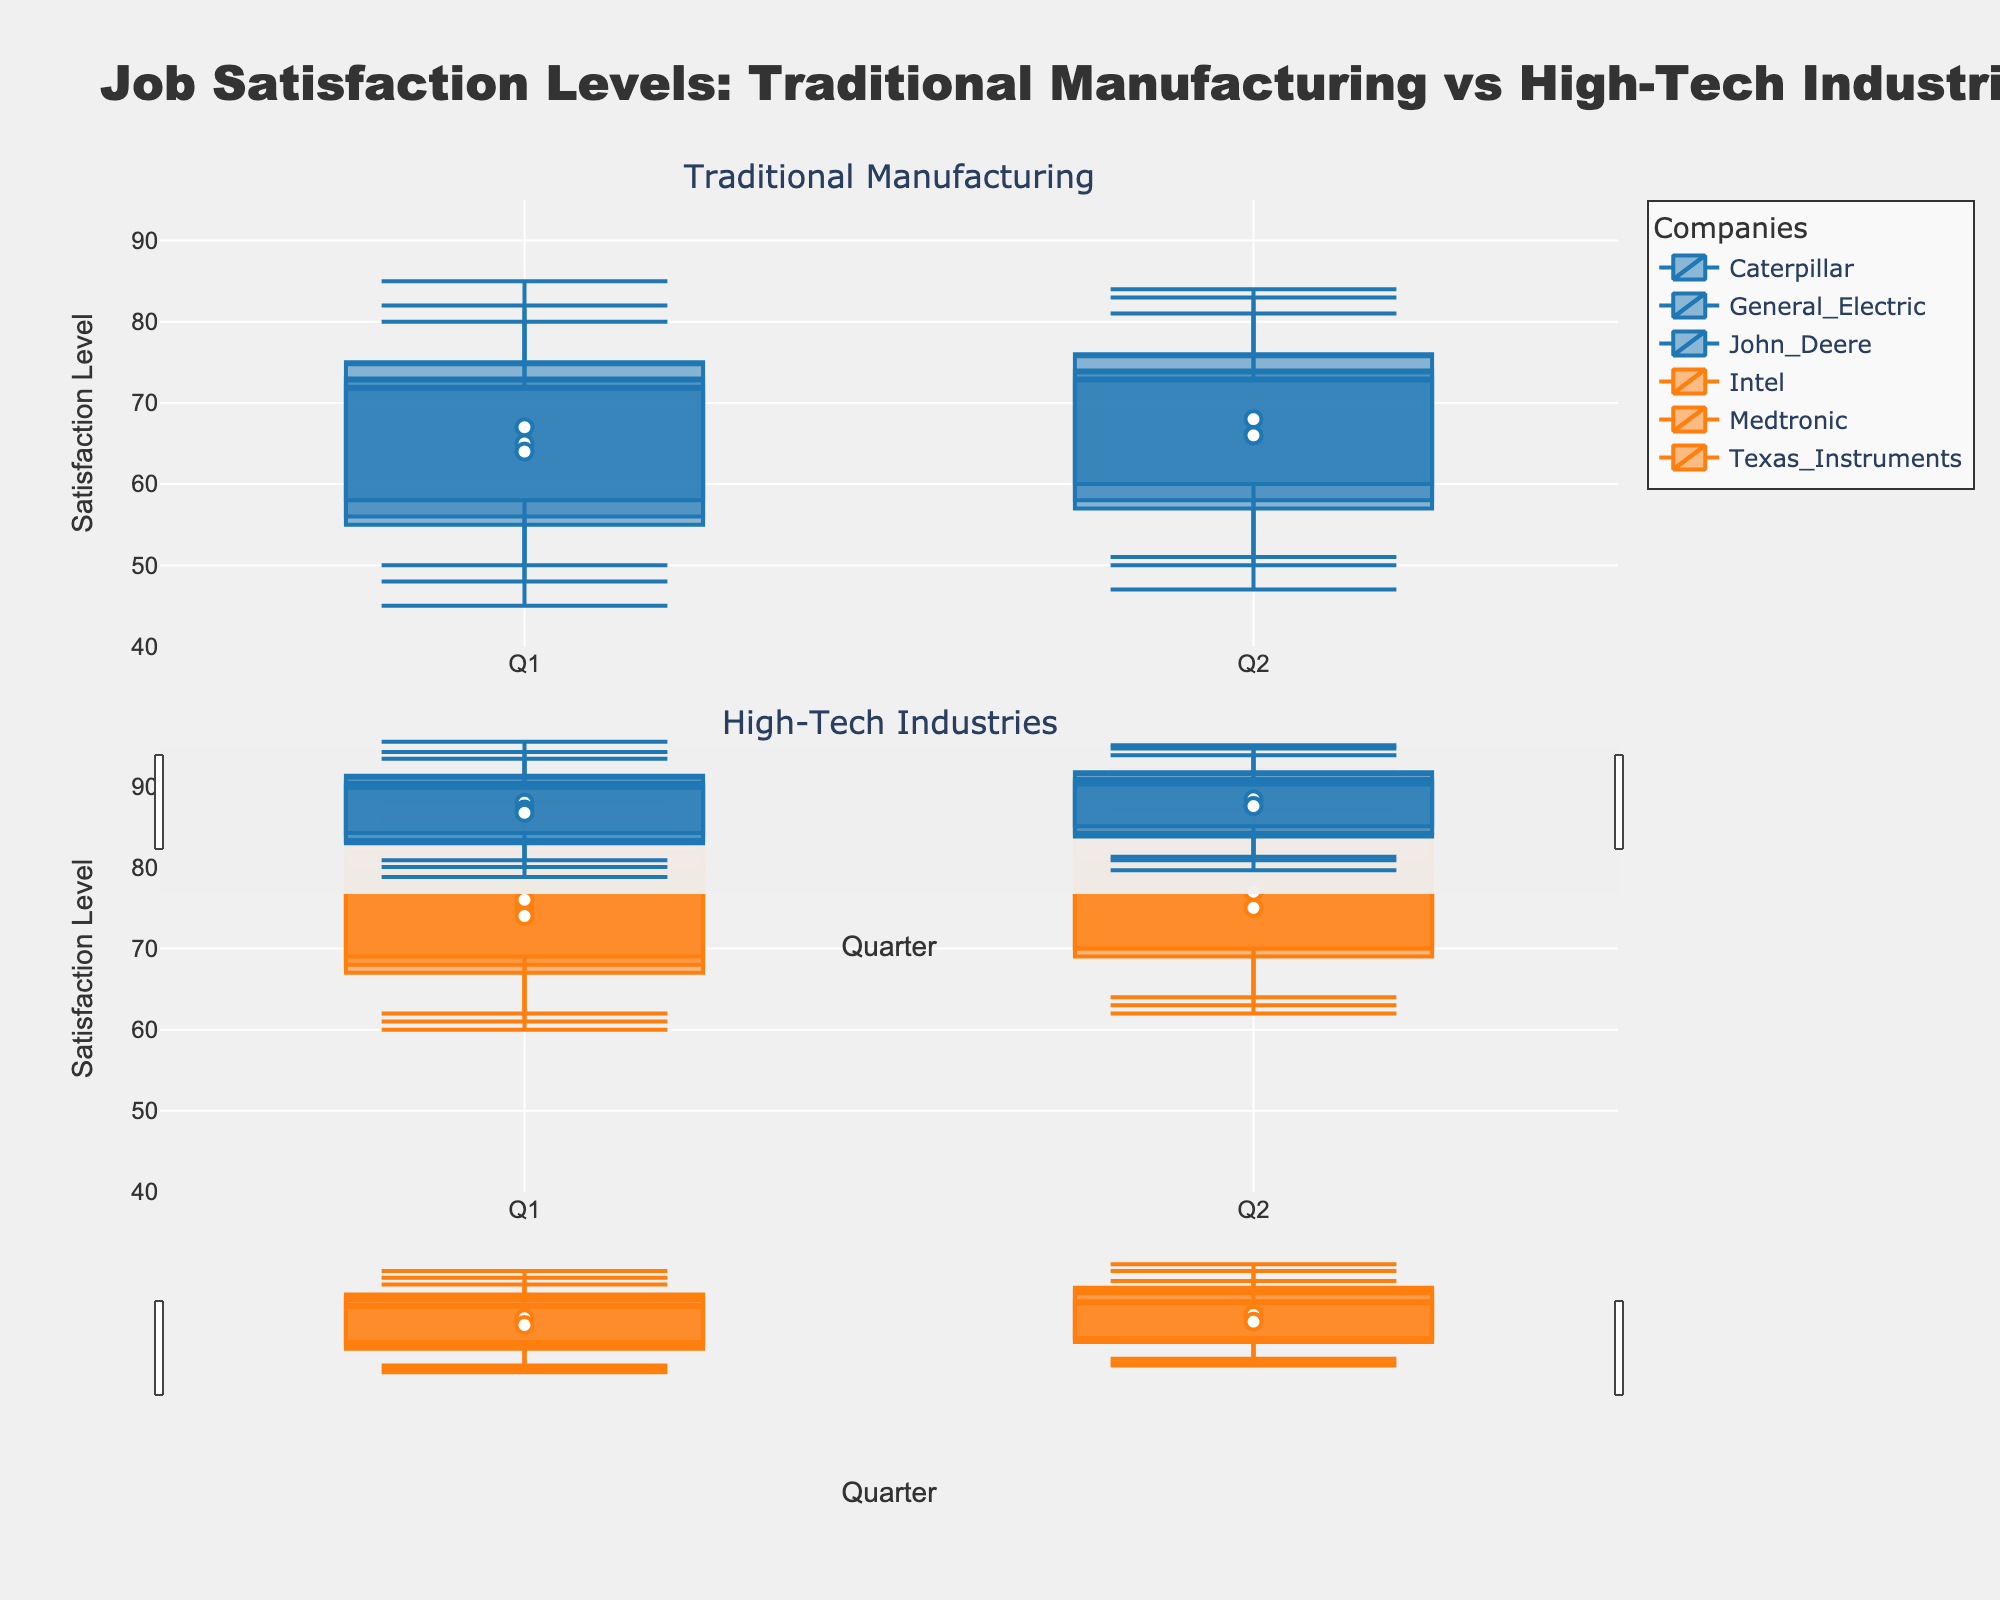Which job type has the higher median job satisfaction levels in Q1? First, I observe the median job satisfaction levels for each company in Q1. For Traditional Manufacturing, the medians are 65, 67, and 64. For High-Tech, the medians are 75, 76, and 74. By comparing these values, I see that High-Tech consistently has higher median job satisfaction levels.
Answer: High-Tech What is the range of job satisfaction levels for General Electric in Q2? To find the range, I subtract the minimum satisfaction level from the maximum. For General Electric in Q2, these values are 47 and 83, respectively. So, 83 - 47 gives the range.
Answer: 36 Which High-Tech company had the lowest minimum satisfaction level in Q1? I look at the minimum satisfaction levels of the High-Tech companies in Q1. Intel has 60, Medtronic has 62, and Texas Instruments has 61. The lowest among them is 60.
Answer: Intel Is the interquartile range for Caterpillar in Q2 greater than that for John Deere in Q2? I find the interquartile ranges by subtracting the first quartile from the third quartile. For Caterpillar in Q2, it's 76 - 60 = 16. For John Deere in Q2, it's 73 - 58 = 15. So, Caterpillar's interquartile range is greater.
Answer: Yes How does the median job satisfaction for Texas Instruments compare from Q1 to Q2? I compare the median values for Texas Instruments from both quarters. In Q1, it’s 74 and in Q2 it’s 75. Hence, there is an increase.
Answer: Increase Which job type shows a wider range of maximum job satisfaction levels across quarters? Traditional Manufacturing's max satisfactions are 85, 82, 80 in Q1, and 83, 84, 81 in Q2. High-Tech's are 90, 88, 86 in Q1, and 92, 90, 87 in Q2. High-Tech shows a wider variation.
Answer: High-Tech Which quarter shows higher overall satisfaction levels for High-Tech companies? I compare the median values and aggregate ranges for High-Tech companies across both quarters. For Q1, the medians are 75, 76, and 74. For Q2, they are 77, 77, and 75. Q2 shows slight improvements.
Answer: Q2 What is the median job satisfaction for companies under High-Tech in Q2? I list the median values for High-Tech companies in Q2 and find the middle number. The medians are 77, 77, and 75. Taking the middle one of a sorted list results in 77.
Answer: 77 